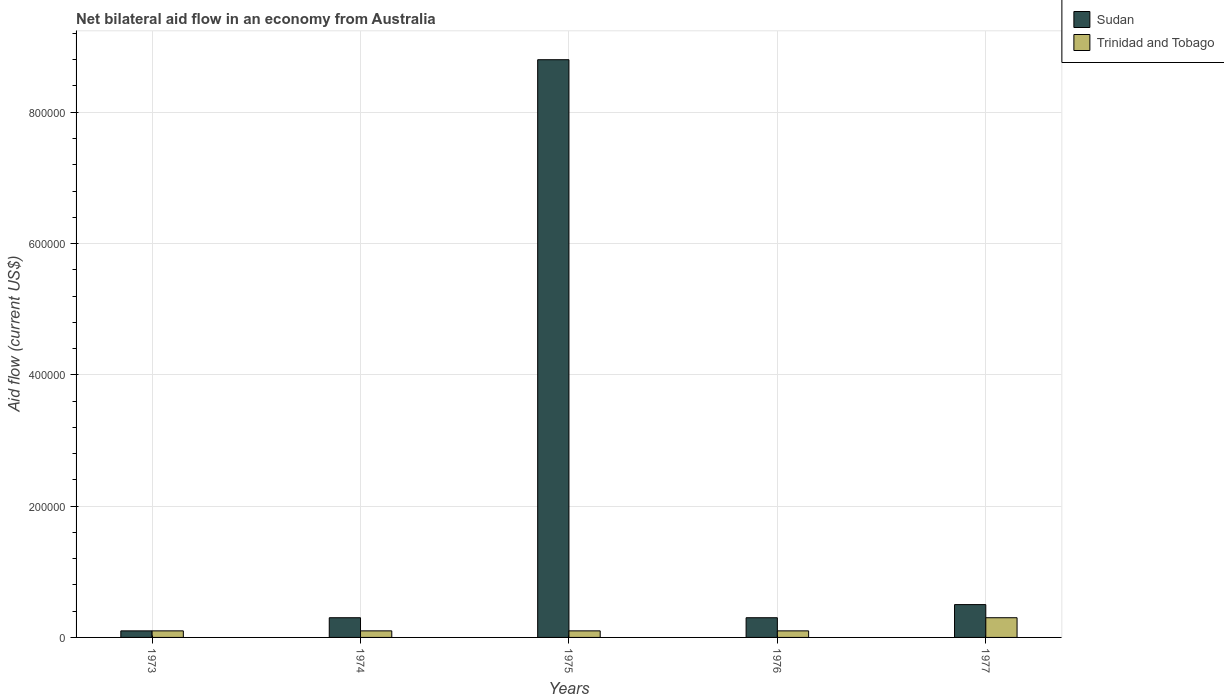Are the number of bars per tick equal to the number of legend labels?
Offer a very short reply. Yes. What is the label of the 3rd group of bars from the left?
Offer a very short reply. 1975. What is the net bilateral aid flow in Trinidad and Tobago in 1973?
Your answer should be compact. 10000. Across all years, what is the maximum net bilateral aid flow in Sudan?
Offer a terse response. 8.80e+05. Across all years, what is the minimum net bilateral aid flow in Sudan?
Make the answer very short. 10000. In which year was the net bilateral aid flow in Sudan minimum?
Your answer should be compact. 1973. What is the difference between the net bilateral aid flow in Sudan in 1975 and that in 1977?
Offer a very short reply. 8.30e+05. What is the difference between the net bilateral aid flow in Trinidad and Tobago in 1973 and the net bilateral aid flow in Sudan in 1974?
Ensure brevity in your answer.  -2.00e+04. What is the average net bilateral aid flow in Trinidad and Tobago per year?
Offer a very short reply. 1.40e+04. What is the ratio of the net bilateral aid flow in Trinidad and Tobago in 1974 to that in 1977?
Ensure brevity in your answer.  0.33. Is the difference between the net bilateral aid flow in Sudan in 1974 and 1977 greater than the difference between the net bilateral aid flow in Trinidad and Tobago in 1974 and 1977?
Your answer should be very brief. No. What is the difference between the highest and the lowest net bilateral aid flow in Sudan?
Provide a succinct answer. 8.70e+05. In how many years, is the net bilateral aid flow in Trinidad and Tobago greater than the average net bilateral aid flow in Trinidad and Tobago taken over all years?
Provide a short and direct response. 1. Is the sum of the net bilateral aid flow in Sudan in 1973 and 1975 greater than the maximum net bilateral aid flow in Trinidad and Tobago across all years?
Offer a terse response. Yes. What does the 2nd bar from the left in 1975 represents?
Make the answer very short. Trinidad and Tobago. What does the 2nd bar from the right in 1975 represents?
Give a very brief answer. Sudan. Are all the bars in the graph horizontal?
Your response must be concise. No. Are the values on the major ticks of Y-axis written in scientific E-notation?
Ensure brevity in your answer.  No. Where does the legend appear in the graph?
Make the answer very short. Top right. How many legend labels are there?
Offer a terse response. 2. How are the legend labels stacked?
Provide a short and direct response. Vertical. What is the title of the graph?
Ensure brevity in your answer.  Net bilateral aid flow in an economy from Australia. What is the label or title of the X-axis?
Make the answer very short. Years. What is the label or title of the Y-axis?
Keep it short and to the point. Aid flow (current US$). What is the Aid flow (current US$) in Sudan in 1974?
Your answer should be very brief. 3.00e+04. What is the Aid flow (current US$) of Trinidad and Tobago in 1974?
Provide a succinct answer. 10000. What is the Aid flow (current US$) in Sudan in 1975?
Keep it short and to the point. 8.80e+05. What is the Aid flow (current US$) in Trinidad and Tobago in 1975?
Your response must be concise. 10000. What is the Aid flow (current US$) in Sudan in 1976?
Keep it short and to the point. 3.00e+04. What is the Aid flow (current US$) in Sudan in 1977?
Keep it short and to the point. 5.00e+04. Across all years, what is the maximum Aid flow (current US$) in Sudan?
Keep it short and to the point. 8.80e+05. Across all years, what is the minimum Aid flow (current US$) in Sudan?
Keep it short and to the point. 10000. Across all years, what is the minimum Aid flow (current US$) of Trinidad and Tobago?
Provide a succinct answer. 10000. What is the total Aid flow (current US$) of Sudan in the graph?
Offer a very short reply. 1.00e+06. What is the difference between the Aid flow (current US$) in Sudan in 1973 and that in 1975?
Give a very brief answer. -8.70e+05. What is the difference between the Aid flow (current US$) in Sudan in 1973 and that in 1976?
Your response must be concise. -2.00e+04. What is the difference between the Aid flow (current US$) of Sudan in 1973 and that in 1977?
Offer a very short reply. -4.00e+04. What is the difference between the Aid flow (current US$) of Trinidad and Tobago in 1973 and that in 1977?
Provide a short and direct response. -2.00e+04. What is the difference between the Aid flow (current US$) of Sudan in 1974 and that in 1975?
Offer a terse response. -8.50e+05. What is the difference between the Aid flow (current US$) of Trinidad and Tobago in 1974 and that in 1975?
Offer a terse response. 0. What is the difference between the Aid flow (current US$) of Sudan in 1974 and that in 1976?
Your answer should be compact. 0. What is the difference between the Aid flow (current US$) in Sudan in 1974 and that in 1977?
Your answer should be very brief. -2.00e+04. What is the difference between the Aid flow (current US$) in Sudan in 1975 and that in 1976?
Your response must be concise. 8.50e+05. What is the difference between the Aid flow (current US$) of Trinidad and Tobago in 1975 and that in 1976?
Ensure brevity in your answer.  0. What is the difference between the Aid flow (current US$) in Sudan in 1975 and that in 1977?
Provide a succinct answer. 8.30e+05. What is the difference between the Aid flow (current US$) in Trinidad and Tobago in 1975 and that in 1977?
Your answer should be compact. -2.00e+04. What is the difference between the Aid flow (current US$) of Sudan in 1976 and that in 1977?
Your answer should be very brief. -2.00e+04. What is the difference between the Aid flow (current US$) of Trinidad and Tobago in 1976 and that in 1977?
Your answer should be very brief. -2.00e+04. What is the difference between the Aid flow (current US$) in Sudan in 1973 and the Aid flow (current US$) in Trinidad and Tobago in 1974?
Keep it short and to the point. 0. What is the difference between the Aid flow (current US$) in Sudan in 1973 and the Aid flow (current US$) in Trinidad and Tobago in 1975?
Provide a succinct answer. 0. What is the difference between the Aid flow (current US$) of Sudan in 1973 and the Aid flow (current US$) of Trinidad and Tobago in 1976?
Your answer should be compact. 0. What is the difference between the Aid flow (current US$) in Sudan in 1973 and the Aid flow (current US$) in Trinidad and Tobago in 1977?
Ensure brevity in your answer.  -2.00e+04. What is the difference between the Aid flow (current US$) in Sudan in 1974 and the Aid flow (current US$) in Trinidad and Tobago in 1975?
Offer a very short reply. 2.00e+04. What is the difference between the Aid flow (current US$) in Sudan in 1974 and the Aid flow (current US$) in Trinidad and Tobago in 1977?
Offer a terse response. 0. What is the difference between the Aid flow (current US$) in Sudan in 1975 and the Aid flow (current US$) in Trinidad and Tobago in 1976?
Make the answer very short. 8.70e+05. What is the difference between the Aid flow (current US$) of Sudan in 1975 and the Aid flow (current US$) of Trinidad and Tobago in 1977?
Ensure brevity in your answer.  8.50e+05. What is the difference between the Aid flow (current US$) of Sudan in 1976 and the Aid flow (current US$) of Trinidad and Tobago in 1977?
Keep it short and to the point. 0. What is the average Aid flow (current US$) of Sudan per year?
Offer a terse response. 2.00e+05. What is the average Aid flow (current US$) of Trinidad and Tobago per year?
Your response must be concise. 1.40e+04. In the year 1975, what is the difference between the Aid flow (current US$) of Sudan and Aid flow (current US$) of Trinidad and Tobago?
Offer a terse response. 8.70e+05. What is the ratio of the Aid flow (current US$) of Sudan in 1973 to that in 1974?
Give a very brief answer. 0.33. What is the ratio of the Aid flow (current US$) in Trinidad and Tobago in 1973 to that in 1974?
Your response must be concise. 1. What is the ratio of the Aid flow (current US$) in Sudan in 1973 to that in 1975?
Keep it short and to the point. 0.01. What is the ratio of the Aid flow (current US$) of Sudan in 1973 to that in 1976?
Make the answer very short. 0.33. What is the ratio of the Aid flow (current US$) in Trinidad and Tobago in 1973 to that in 1976?
Keep it short and to the point. 1. What is the ratio of the Aid flow (current US$) of Trinidad and Tobago in 1973 to that in 1977?
Offer a terse response. 0.33. What is the ratio of the Aid flow (current US$) of Sudan in 1974 to that in 1975?
Offer a terse response. 0.03. What is the ratio of the Aid flow (current US$) of Trinidad and Tobago in 1974 to that in 1975?
Offer a terse response. 1. What is the ratio of the Aid flow (current US$) of Trinidad and Tobago in 1974 to that in 1976?
Your response must be concise. 1. What is the ratio of the Aid flow (current US$) in Trinidad and Tobago in 1974 to that in 1977?
Give a very brief answer. 0.33. What is the ratio of the Aid flow (current US$) in Sudan in 1975 to that in 1976?
Offer a very short reply. 29.33. What is the ratio of the Aid flow (current US$) in Trinidad and Tobago in 1975 to that in 1976?
Ensure brevity in your answer.  1. What is the ratio of the Aid flow (current US$) of Sudan in 1975 to that in 1977?
Keep it short and to the point. 17.6. What is the ratio of the Aid flow (current US$) of Sudan in 1976 to that in 1977?
Make the answer very short. 0.6. What is the difference between the highest and the second highest Aid flow (current US$) in Sudan?
Ensure brevity in your answer.  8.30e+05. What is the difference between the highest and the lowest Aid flow (current US$) of Sudan?
Your answer should be very brief. 8.70e+05. 